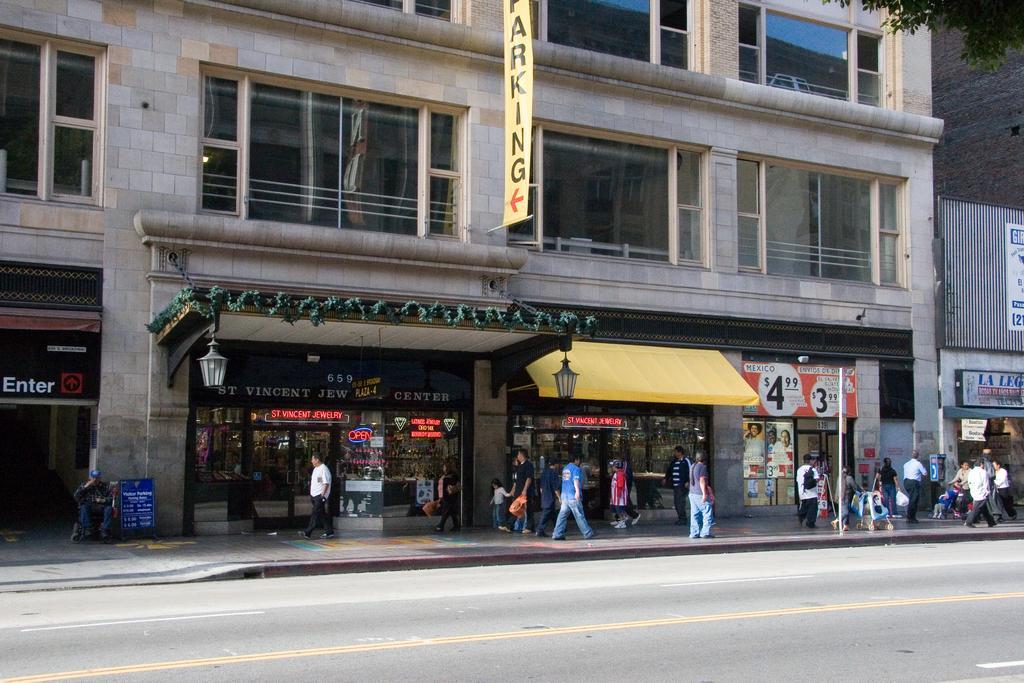Describe this image in one or two sentences. In this image I can see a road in the front. In the background I can see number of people are walking on the footpath. I can also see few buildings, number of stores, number of boards, two lights and on these boards I can see something is written. On the top right corner of this image I can see leaves of a tree. 